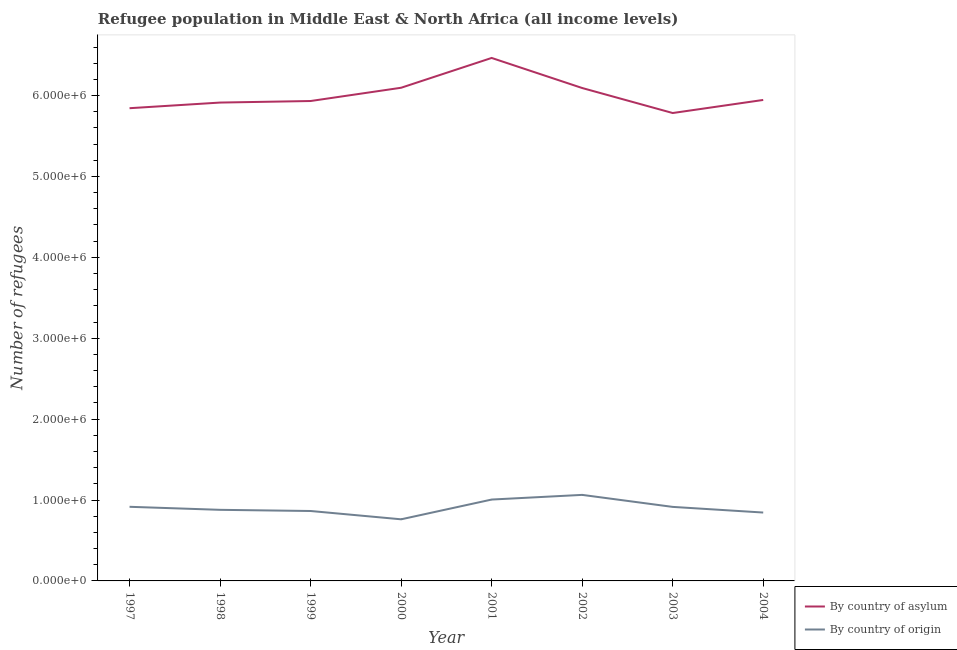How many different coloured lines are there?
Offer a terse response. 2. Is the number of lines equal to the number of legend labels?
Ensure brevity in your answer.  Yes. What is the number of refugees by country of origin in 1998?
Your answer should be very brief. 8.79e+05. Across all years, what is the maximum number of refugees by country of origin?
Make the answer very short. 1.06e+06. Across all years, what is the minimum number of refugees by country of asylum?
Offer a terse response. 5.78e+06. In which year was the number of refugees by country of asylum maximum?
Offer a terse response. 2001. What is the total number of refugees by country of origin in the graph?
Keep it short and to the point. 7.25e+06. What is the difference between the number of refugees by country of origin in 1997 and that in 1999?
Your answer should be very brief. 5.20e+04. What is the difference between the number of refugees by country of origin in 2003 and the number of refugees by country of asylum in 1997?
Make the answer very short. -4.93e+06. What is the average number of refugees by country of origin per year?
Make the answer very short. 9.06e+05. In the year 2002, what is the difference between the number of refugees by country of origin and number of refugees by country of asylum?
Provide a succinct answer. -5.03e+06. In how many years, is the number of refugees by country of origin greater than 4600000?
Your response must be concise. 0. What is the ratio of the number of refugees by country of origin in 2001 to that in 2002?
Offer a terse response. 0.95. What is the difference between the highest and the second highest number of refugees by country of origin?
Offer a terse response. 5.77e+04. What is the difference between the highest and the lowest number of refugees by country of origin?
Your answer should be compact. 3.02e+05. In how many years, is the number of refugees by country of asylum greater than the average number of refugees by country of asylum taken over all years?
Your response must be concise. 3. Is the sum of the number of refugees by country of asylum in 1997 and 2001 greater than the maximum number of refugees by country of origin across all years?
Your response must be concise. Yes. Is the number of refugees by country of origin strictly greater than the number of refugees by country of asylum over the years?
Your answer should be compact. No. Is the number of refugees by country of origin strictly less than the number of refugees by country of asylum over the years?
Offer a terse response. Yes. Are the values on the major ticks of Y-axis written in scientific E-notation?
Your response must be concise. Yes. Does the graph contain any zero values?
Your answer should be compact. No. Where does the legend appear in the graph?
Keep it short and to the point. Bottom right. How are the legend labels stacked?
Ensure brevity in your answer.  Vertical. What is the title of the graph?
Ensure brevity in your answer.  Refugee population in Middle East & North Africa (all income levels). What is the label or title of the Y-axis?
Your response must be concise. Number of refugees. What is the Number of refugees of By country of asylum in 1997?
Give a very brief answer. 5.84e+06. What is the Number of refugees of By country of origin in 1997?
Your response must be concise. 9.16e+05. What is the Number of refugees of By country of asylum in 1998?
Offer a terse response. 5.91e+06. What is the Number of refugees in By country of origin in 1998?
Ensure brevity in your answer.  8.79e+05. What is the Number of refugees in By country of asylum in 1999?
Your answer should be compact. 5.93e+06. What is the Number of refugees in By country of origin in 1999?
Your response must be concise. 8.64e+05. What is the Number of refugees of By country of asylum in 2000?
Provide a short and direct response. 6.10e+06. What is the Number of refugees in By country of origin in 2000?
Keep it short and to the point. 7.62e+05. What is the Number of refugees in By country of asylum in 2001?
Your response must be concise. 6.46e+06. What is the Number of refugees of By country of origin in 2001?
Give a very brief answer. 1.01e+06. What is the Number of refugees in By country of asylum in 2002?
Ensure brevity in your answer.  6.09e+06. What is the Number of refugees of By country of origin in 2002?
Make the answer very short. 1.06e+06. What is the Number of refugees in By country of asylum in 2003?
Your answer should be very brief. 5.78e+06. What is the Number of refugees in By country of origin in 2003?
Keep it short and to the point. 9.15e+05. What is the Number of refugees in By country of asylum in 2004?
Provide a succinct answer. 5.95e+06. What is the Number of refugees of By country of origin in 2004?
Provide a succinct answer. 8.45e+05. Across all years, what is the maximum Number of refugees in By country of asylum?
Your answer should be very brief. 6.46e+06. Across all years, what is the maximum Number of refugees in By country of origin?
Ensure brevity in your answer.  1.06e+06. Across all years, what is the minimum Number of refugees of By country of asylum?
Ensure brevity in your answer.  5.78e+06. Across all years, what is the minimum Number of refugees of By country of origin?
Make the answer very short. 7.62e+05. What is the total Number of refugees in By country of asylum in the graph?
Your answer should be very brief. 4.81e+07. What is the total Number of refugees of By country of origin in the graph?
Make the answer very short. 7.25e+06. What is the difference between the Number of refugees of By country of asylum in 1997 and that in 1998?
Provide a short and direct response. -6.97e+04. What is the difference between the Number of refugees of By country of origin in 1997 and that in 1998?
Ensure brevity in your answer.  3.76e+04. What is the difference between the Number of refugees of By country of asylum in 1997 and that in 1999?
Offer a very short reply. -8.89e+04. What is the difference between the Number of refugees of By country of origin in 1997 and that in 1999?
Your response must be concise. 5.20e+04. What is the difference between the Number of refugees in By country of asylum in 1997 and that in 2000?
Offer a very short reply. -2.53e+05. What is the difference between the Number of refugees in By country of origin in 1997 and that in 2000?
Provide a short and direct response. 1.55e+05. What is the difference between the Number of refugees of By country of asylum in 1997 and that in 2001?
Your answer should be very brief. -6.21e+05. What is the difference between the Number of refugees in By country of origin in 1997 and that in 2001?
Your answer should be very brief. -8.96e+04. What is the difference between the Number of refugees in By country of asylum in 1997 and that in 2002?
Give a very brief answer. -2.50e+05. What is the difference between the Number of refugees in By country of origin in 1997 and that in 2002?
Give a very brief answer. -1.47e+05. What is the difference between the Number of refugees of By country of asylum in 1997 and that in 2003?
Your answer should be very brief. 5.96e+04. What is the difference between the Number of refugees in By country of origin in 1997 and that in 2003?
Give a very brief answer. 1227. What is the difference between the Number of refugees in By country of asylum in 1997 and that in 2004?
Your response must be concise. -1.02e+05. What is the difference between the Number of refugees in By country of origin in 1997 and that in 2004?
Make the answer very short. 7.10e+04. What is the difference between the Number of refugees of By country of asylum in 1998 and that in 1999?
Your answer should be very brief. -1.92e+04. What is the difference between the Number of refugees of By country of origin in 1998 and that in 1999?
Ensure brevity in your answer.  1.44e+04. What is the difference between the Number of refugees in By country of asylum in 1998 and that in 2000?
Keep it short and to the point. -1.83e+05. What is the difference between the Number of refugees in By country of origin in 1998 and that in 2000?
Keep it short and to the point. 1.17e+05. What is the difference between the Number of refugees in By country of asylum in 1998 and that in 2001?
Provide a short and direct response. -5.52e+05. What is the difference between the Number of refugees in By country of origin in 1998 and that in 2001?
Provide a short and direct response. -1.27e+05. What is the difference between the Number of refugees in By country of asylum in 1998 and that in 2002?
Make the answer very short. -1.80e+05. What is the difference between the Number of refugees of By country of origin in 1998 and that in 2002?
Offer a very short reply. -1.85e+05. What is the difference between the Number of refugees of By country of asylum in 1998 and that in 2003?
Your response must be concise. 1.29e+05. What is the difference between the Number of refugees in By country of origin in 1998 and that in 2003?
Your answer should be very brief. -3.64e+04. What is the difference between the Number of refugees of By country of asylum in 1998 and that in 2004?
Offer a very short reply. -3.24e+04. What is the difference between the Number of refugees in By country of origin in 1998 and that in 2004?
Offer a terse response. 3.34e+04. What is the difference between the Number of refugees in By country of asylum in 1999 and that in 2000?
Offer a very short reply. -1.64e+05. What is the difference between the Number of refugees in By country of origin in 1999 and that in 2000?
Your answer should be very brief. 1.03e+05. What is the difference between the Number of refugees in By country of asylum in 1999 and that in 2001?
Provide a short and direct response. -5.32e+05. What is the difference between the Number of refugees in By country of origin in 1999 and that in 2001?
Your response must be concise. -1.42e+05. What is the difference between the Number of refugees in By country of asylum in 1999 and that in 2002?
Your answer should be compact. -1.61e+05. What is the difference between the Number of refugees in By country of origin in 1999 and that in 2002?
Offer a terse response. -1.99e+05. What is the difference between the Number of refugees of By country of asylum in 1999 and that in 2003?
Give a very brief answer. 1.48e+05. What is the difference between the Number of refugees of By country of origin in 1999 and that in 2003?
Offer a very short reply. -5.08e+04. What is the difference between the Number of refugees of By country of asylum in 1999 and that in 2004?
Keep it short and to the point. -1.32e+04. What is the difference between the Number of refugees of By country of origin in 1999 and that in 2004?
Keep it short and to the point. 1.90e+04. What is the difference between the Number of refugees in By country of asylum in 2000 and that in 2001?
Provide a short and direct response. -3.68e+05. What is the difference between the Number of refugees in By country of origin in 2000 and that in 2001?
Your response must be concise. -2.44e+05. What is the difference between the Number of refugees of By country of asylum in 2000 and that in 2002?
Your answer should be compact. 3308. What is the difference between the Number of refugees in By country of origin in 2000 and that in 2002?
Ensure brevity in your answer.  -3.02e+05. What is the difference between the Number of refugees of By country of asylum in 2000 and that in 2003?
Provide a succinct answer. 3.12e+05. What is the difference between the Number of refugees in By country of origin in 2000 and that in 2003?
Provide a succinct answer. -1.53e+05. What is the difference between the Number of refugees of By country of asylum in 2000 and that in 2004?
Your answer should be compact. 1.51e+05. What is the difference between the Number of refugees of By country of origin in 2000 and that in 2004?
Ensure brevity in your answer.  -8.37e+04. What is the difference between the Number of refugees in By country of asylum in 2001 and that in 2002?
Offer a terse response. 3.72e+05. What is the difference between the Number of refugees in By country of origin in 2001 and that in 2002?
Offer a terse response. -5.77e+04. What is the difference between the Number of refugees in By country of asylum in 2001 and that in 2003?
Provide a short and direct response. 6.81e+05. What is the difference between the Number of refugees of By country of origin in 2001 and that in 2003?
Provide a short and direct response. 9.08e+04. What is the difference between the Number of refugees in By country of asylum in 2001 and that in 2004?
Offer a terse response. 5.19e+05. What is the difference between the Number of refugees in By country of origin in 2001 and that in 2004?
Keep it short and to the point. 1.61e+05. What is the difference between the Number of refugees of By country of asylum in 2002 and that in 2003?
Make the answer very short. 3.09e+05. What is the difference between the Number of refugees of By country of origin in 2002 and that in 2003?
Make the answer very short. 1.48e+05. What is the difference between the Number of refugees in By country of asylum in 2002 and that in 2004?
Keep it short and to the point. 1.48e+05. What is the difference between the Number of refugees of By country of origin in 2002 and that in 2004?
Provide a short and direct response. 2.18e+05. What is the difference between the Number of refugees of By country of asylum in 2003 and that in 2004?
Your answer should be very brief. -1.62e+05. What is the difference between the Number of refugees of By country of origin in 2003 and that in 2004?
Your response must be concise. 6.98e+04. What is the difference between the Number of refugees of By country of asylum in 1997 and the Number of refugees of By country of origin in 1998?
Offer a very short reply. 4.96e+06. What is the difference between the Number of refugees of By country of asylum in 1997 and the Number of refugees of By country of origin in 1999?
Provide a succinct answer. 4.98e+06. What is the difference between the Number of refugees in By country of asylum in 1997 and the Number of refugees in By country of origin in 2000?
Provide a succinct answer. 5.08e+06. What is the difference between the Number of refugees of By country of asylum in 1997 and the Number of refugees of By country of origin in 2001?
Your answer should be compact. 4.84e+06. What is the difference between the Number of refugees of By country of asylum in 1997 and the Number of refugees of By country of origin in 2002?
Your answer should be compact. 4.78e+06. What is the difference between the Number of refugees in By country of asylum in 1997 and the Number of refugees in By country of origin in 2003?
Give a very brief answer. 4.93e+06. What is the difference between the Number of refugees in By country of asylum in 1997 and the Number of refugees in By country of origin in 2004?
Your answer should be very brief. 5.00e+06. What is the difference between the Number of refugees in By country of asylum in 1998 and the Number of refugees in By country of origin in 1999?
Provide a succinct answer. 5.05e+06. What is the difference between the Number of refugees of By country of asylum in 1998 and the Number of refugees of By country of origin in 2000?
Make the answer very short. 5.15e+06. What is the difference between the Number of refugees of By country of asylum in 1998 and the Number of refugees of By country of origin in 2001?
Keep it short and to the point. 4.91e+06. What is the difference between the Number of refugees of By country of asylum in 1998 and the Number of refugees of By country of origin in 2002?
Offer a very short reply. 4.85e+06. What is the difference between the Number of refugees of By country of asylum in 1998 and the Number of refugees of By country of origin in 2003?
Make the answer very short. 5.00e+06. What is the difference between the Number of refugees of By country of asylum in 1998 and the Number of refugees of By country of origin in 2004?
Make the answer very short. 5.07e+06. What is the difference between the Number of refugees in By country of asylum in 1999 and the Number of refugees in By country of origin in 2000?
Keep it short and to the point. 5.17e+06. What is the difference between the Number of refugees of By country of asylum in 1999 and the Number of refugees of By country of origin in 2001?
Provide a succinct answer. 4.93e+06. What is the difference between the Number of refugees in By country of asylum in 1999 and the Number of refugees in By country of origin in 2002?
Offer a terse response. 4.87e+06. What is the difference between the Number of refugees of By country of asylum in 1999 and the Number of refugees of By country of origin in 2003?
Give a very brief answer. 5.02e+06. What is the difference between the Number of refugees in By country of asylum in 1999 and the Number of refugees in By country of origin in 2004?
Offer a terse response. 5.09e+06. What is the difference between the Number of refugees of By country of asylum in 2000 and the Number of refugees of By country of origin in 2001?
Offer a very short reply. 5.09e+06. What is the difference between the Number of refugees in By country of asylum in 2000 and the Number of refugees in By country of origin in 2002?
Your response must be concise. 5.03e+06. What is the difference between the Number of refugees of By country of asylum in 2000 and the Number of refugees of By country of origin in 2003?
Offer a very short reply. 5.18e+06. What is the difference between the Number of refugees of By country of asylum in 2000 and the Number of refugees of By country of origin in 2004?
Your answer should be very brief. 5.25e+06. What is the difference between the Number of refugees in By country of asylum in 2001 and the Number of refugees in By country of origin in 2002?
Make the answer very short. 5.40e+06. What is the difference between the Number of refugees in By country of asylum in 2001 and the Number of refugees in By country of origin in 2003?
Provide a short and direct response. 5.55e+06. What is the difference between the Number of refugees in By country of asylum in 2001 and the Number of refugees in By country of origin in 2004?
Keep it short and to the point. 5.62e+06. What is the difference between the Number of refugees of By country of asylum in 2002 and the Number of refugees of By country of origin in 2003?
Ensure brevity in your answer.  5.18e+06. What is the difference between the Number of refugees of By country of asylum in 2002 and the Number of refugees of By country of origin in 2004?
Ensure brevity in your answer.  5.25e+06. What is the difference between the Number of refugees of By country of asylum in 2003 and the Number of refugees of By country of origin in 2004?
Provide a short and direct response. 4.94e+06. What is the average Number of refugees of By country of asylum per year?
Offer a terse response. 6.01e+06. What is the average Number of refugees of By country of origin per year?
Your answer should be compact. 9.06e+05. In the year 1997, what is the difference between the Number of refugees of By country of asylum and Number of refugees of By country of origin?
Offer a very short reply. 4.93e+06. In the year 1998, what is the difference between the Number of refugees in By country of asylum and Number of refugees in By country of origin?
Make the answer very short. 5.03e+06. In the year 1999, what is the difference between the Number of refugees of By country of asylum and Number of refugees of By country of origin?
Your answer should be compact. 5.07e+06. In the year 2000, what is the difference between the Number of refugees of By country of asylum and Number of refugees of By country of origin?
Keep it short and to the point. 5.33e+06. In the year 2001, what is the difference between the Number of refugees in By country of asylum and Number of refugees in By country of origin?
Offer a terse response. 5.46e+06. In the year 2002, what is the difference between the Number of refugees in By country of asylum and Number of refugees in By country of origin?
Ensure brevity in your answer.  5.03e+06. In the year 2003, what is the difference between the Number of refugees in By country of asylum and Number of refugees in By country of origin?
Your answer should be very brief. 4.87e+06. In the year 2004, what is the difference between the Number of refugees in By country of asylum and Number of refugees in By country of origin?
Your answer should be very brief. 5.10e+06. What is the ratio of the Number of refugees in By country of origin in 1997 to that in 1998?
Offer a very short reply. 1.04. What is the ratio of the Number of refugees of By country of origin in 1997 to that in 1999?
Ensure brevity in your answer.  1.06. What is the ratio of the Number of refugees in By country of asylum in 1997 to that in 2000?
Your answer should be compact. 0.96. What is the ratio of the Number of refugees in By country of origin in 1997 to that in 2000?
Offer a terse response. 1.2. What is the ratio of the Number of refugees of By country of asylum in 1997 to that in 2001?
Your answer should be compact. 0.9. What is the ratio of the Number of refugees in By country of origin in 1997 to that in 2001?
Offer a terse response. 0.91. What is the ratio of the Number of refugees in By country of asylum in 1997 to that in 2002?
Ensure brevity in your answer.  0.96. What is the ratio of the Number of refugees in By country of origin in 1997 to that in 2002?
Give a very brief answer. 0.86. What is the ratio of the Number of refugees in By country of asylum in 1997 to that in 2003?
Give a very brief answer. 1.01. What is the ratio of the Number of refugees of By country of origin in 1997 to that in 2003?
Offer a terse response. 1. What is the ratio of the Number of refugees in By country of asylum in 1997 to that in 2004?
Keep it short and to the point. 0.98. What is the ratio of the Number of refugees in By country of origin in 1997 to that in 2004?
Give a very brief answer. 1.08. What is the ratio of the Number of refugees of By country of origin in 1998 to that in 1999?
Your answer should be compact. 1.02. What is the ratio of the Number of refugees in By country of asylum in 1998 to that in 2000?
Ensure brevity in your answer.  0.97. What is the ratio of the Number of refugees of By country of origin in 1998 to that in 2000?
Give a very brief answer. 1.15. What is the ratio of the Number of refugees of By country of asylum in 1998 to that in 2001?
Provide a short and direct response. 0.91. What is the ratio of the Number of refugees in By country of origin in 1998 to that in 2001?
Your response must be concise. 0.87. What is the ratio of the Number of refugees of By country of asylum in 1998 to that in 2002?
Offer a terse response. 0.97. What is the ratio of the Number of refugees of By country of origin in 1998 to that in 2002?
Make the answer very short. 0.83. What is the ratio of the Number of refugees of By country of asylum in 1998 to that in 2003?
Provide a short and direct response. 1.02. What is the ratio of the Number of refugees in By country of origin in 1998 to that in 2003?
Offer a terse response. 0.96. What is the ratio of the Number of refugees of By country of origin in 1998 to that in 2004?
Ensure brevity in your answer.  1.04. What is the ratio of the Number of refugees in By country of asylum in 1999 to that in 2000?
Give a very brief answer. 0.97. What is the ratio of the Number of refugees of By country of origin in 1999 to that in 2000?
Offer a terse response. 1.13. What is the ratio of the Number of refugees of By country of asylum in 1999 to that in 2001?
Your response must be concise. 0.92. What is the ratio of the Number of refugees of By country of origin in 1999 to that in 2001?
Your answer should be very brief. 0.86. What is the ratio of the Number of refugees in By country of asylum in 1999 to that in 2002?
Provide a succinct answer. 0.97. What is the ratio of the Number of refugees of By country of origin in 1999 to that in 2002?
Provide a succinct answer. 0.81. What is the ratio of the Number of refugees in By country of asylum in 1999 to that in 2003?
Your response must be concise. 1.03. What is the ratio of the Number of refugees of By country of origin in 1999 to that in 2003?
Offer a terse response. 0.94. What is the ratio of the Number of refugees in By country of asylum in 1999 to that in 2004?
Provide a short and direct response. 1. What is the ratio of the Number of refugees of By country of origin in 1999 to that in 2004?
Give a very brief answer. 1.02. What is the ratio of the Number of refugees in By country of asylum in 2000 to that in 2001?
Your answer should be compact. 0.94. What is the ratio of the Number of refugees of By country of origin in 2000 to that in 2001?
Make the answer very short. 0.76. What is the ratio of the Number of refugees in By country of origin in 2000 to that in 2002?
Your answer should be very brief. 0.72. What is the ratio of the Number of refugees of By country of asylum in 2000 to that in 2003?
Keep it short and to the point. 1.05. What is the ratio of the Number of refugees of By country of origin in 2000 to that in 2003?
Make the answer very short. 0.83. What is the ratio of the Number of refugees in By country of asylum in 2000 to that in 2004?
Keep it short and to the point. 1.03. What is the ratio of the Number of refugees in By country of origin in 2000 to that in 2004?
Offer a terse response. 0.9. What is the ratio of the Number of refugees in By country of asylum in 2001 to that in 2002?
Make the answer very short. 1.06. What is the ratio of the Number of refugees of By country of origin in 2001 to that in 2002?
Offer a very short reply. 0.95. What is the ratio of the Number of refugees in By country of asylum in 2001 to that in 2003?
Your answer should be compact. 1.12. What is the ratio of the Number of refugees of By country of origin in 2001 to that in 2003?
Offer a terse response. 1.1. What is the ratio of the Number of refugees in By country of asylum in 2001 to that in 2004?
Offer a terse response. 1.09. What is the ratio of the Number of refugees of By country of origin in 2001 to that in 2004?
Ensure brevity in your answer.  1.19. What is the ratio of the Number of refugees of By country of asylum in 2002 to that in 2003?
Make the answer very short. 1.05. What is the ratio of the Number of refugees of By country of origin in 2002 to that in 2003?
Provide a short and direct response. 1.16. What is the ratio of the Number of refugees of By country of asylum in 2002 to that in 2004?
Ensure brevity in your answer.  1.02. What is the ratio of the Number of refugees of By country of origin in 2002 to that in 2004?
Offer a terse response. 1.26. What is the ratio of the Number of refugees of By country of asylum in 2003 to that in 2004?
Make the answer very short. 0.97. What is the ratio of the Number of refugees in By country of origin in 2003 to that in 2004?
Ensure brevity in your answer.  1.08. What is the difference between the highest and the second highest Number of refugees of By country of asylum?
Provide a succinct answer. 3.68e+05. What is the difference between the highest and the second highest Number of refugees in By country of origin?
Your response must be concise. 5.77e+04. What is the difference between the highest and the lowest Number of refugees in By country of asylum?
Make the answer very short. 6.81e+05. What is the difference between the highest and the lowest Number of refugees of By country of origin?
Make the answer very short. 3.02e+05. 